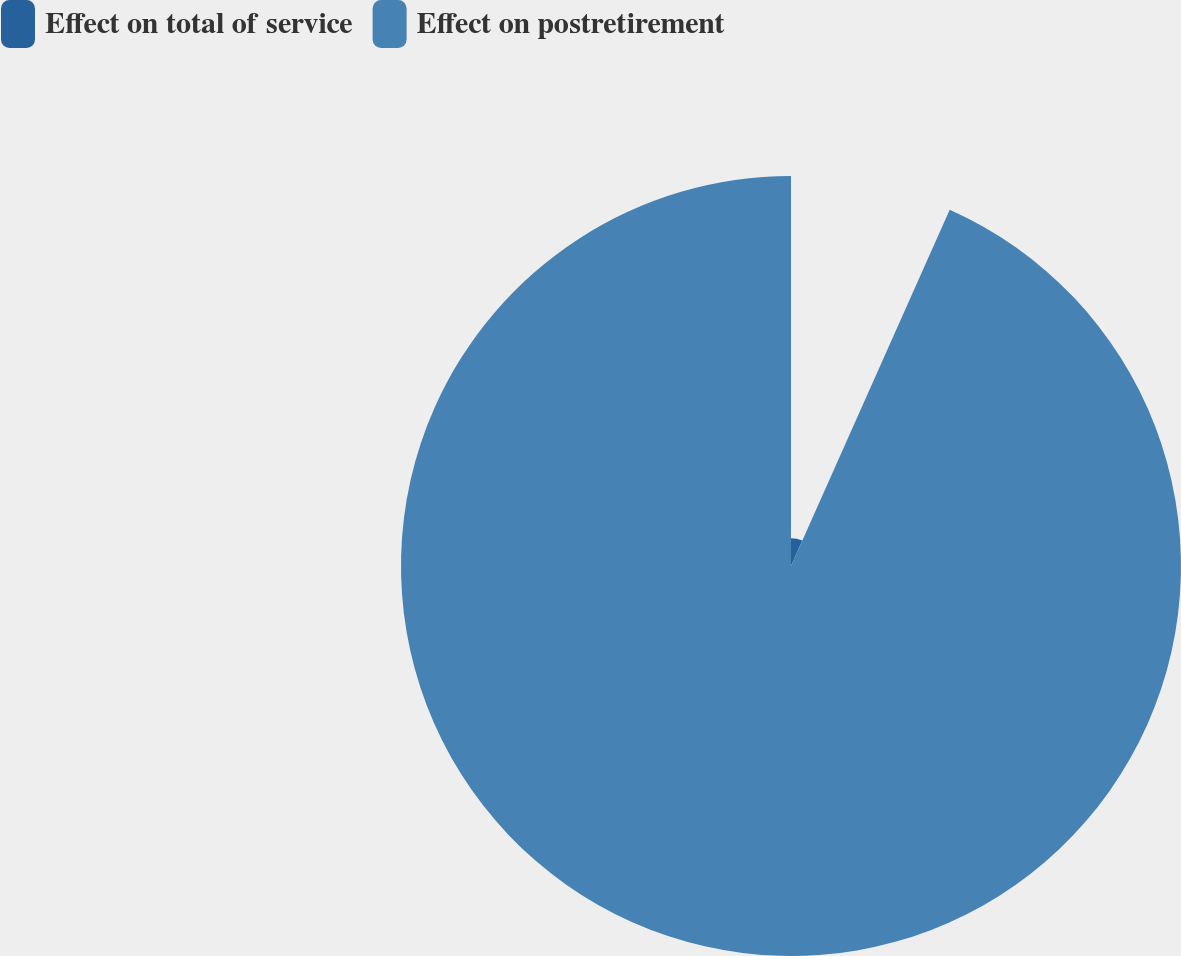Convert chart to OTSL. <chart><loc_0><loc_0><loc_500><loc_500><pie_chart><fcel>Effect on total of service<fcel>Effect on postretirement<nl><fcel>6.67%<fcel>93.33%<nl></chart> 